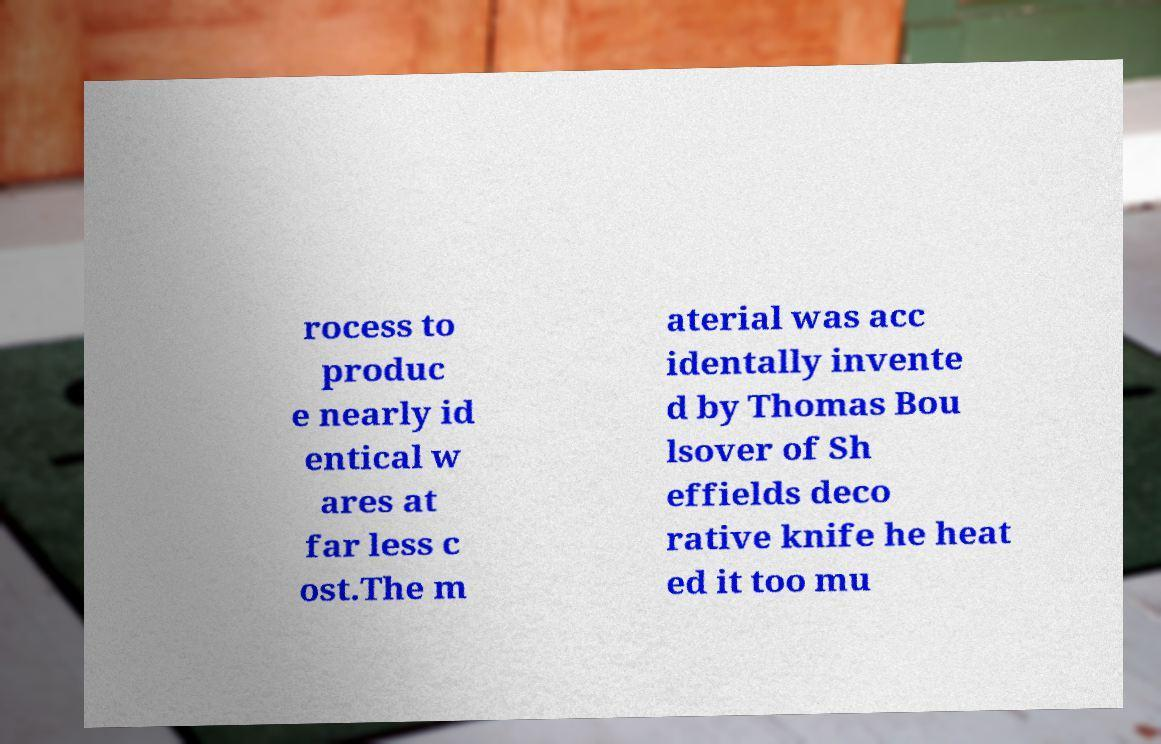There's text embedded in this image that I need extracted. Can you transcribe it verbatim? rocess to produc e nearly id entical w ares at far less c ost.The m aterial was acc identally invente d by Thomas Bou lsover of Sh effields deco rative knife he heat ed it too mu 